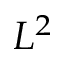Convert formula to latex. <formula><loc_0><loc_0><loc_500><loc_500>L ^ { 2 }</formula> 